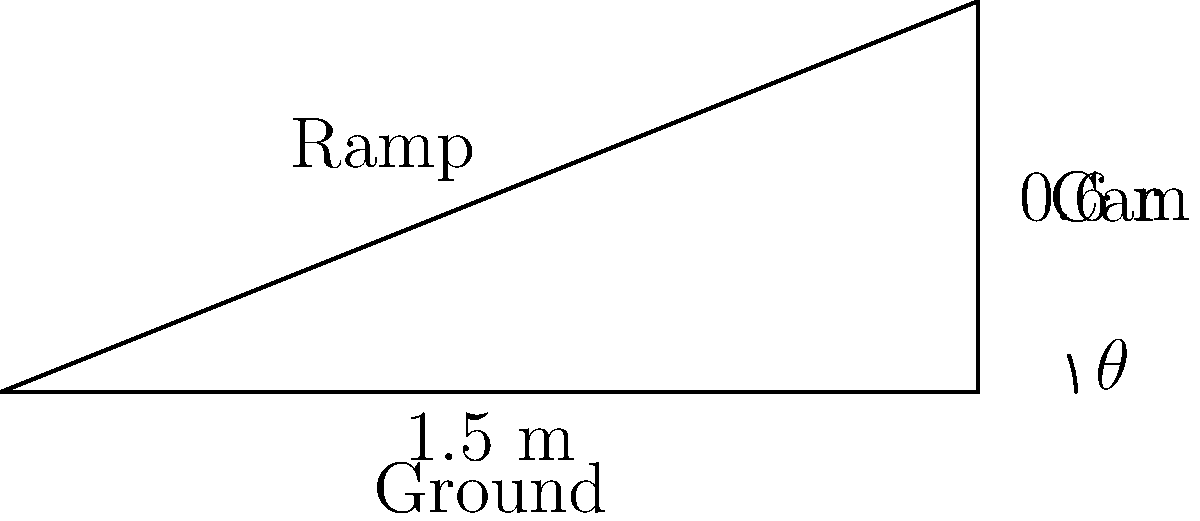You want to create a ramp for your energetic puppy to easily climb into your car. The height from the ground to the car floor is 0.6 meters, and you have a 1.5-meter long ramp. What angle $\theta$ should the ramp make with the ground to provide an easy incline for your puppy? To find the angle $\theta$, we can use the inverse sine (arcsin) function. Here's how:

1) In this right-angled triangle:
   - The opposite side is the height: 0.6 m
   - The hypotenuse is the ramp length: 1.5 m

2) We use the sine function: $\sin(\theta) = \frac{\text{opposite}}{\text{hypotenuse}}$

3) Substituting our values:
   $\sin(\theta) = \frac{0.6}{1.5} = 0.4$

4) To find $\theta$, we take the inverse sine (arcsin) of both sides:
   $\theta = \arcsin(0.4)$

5) Calculate this value:
   $\theta \approx 23.5781°$

6) Round to one decimal place:
   $\theta \approx 23.6°$

This angle should provide an easy incline for your puppy to climb into the car.
Answer: $23.6°$ 